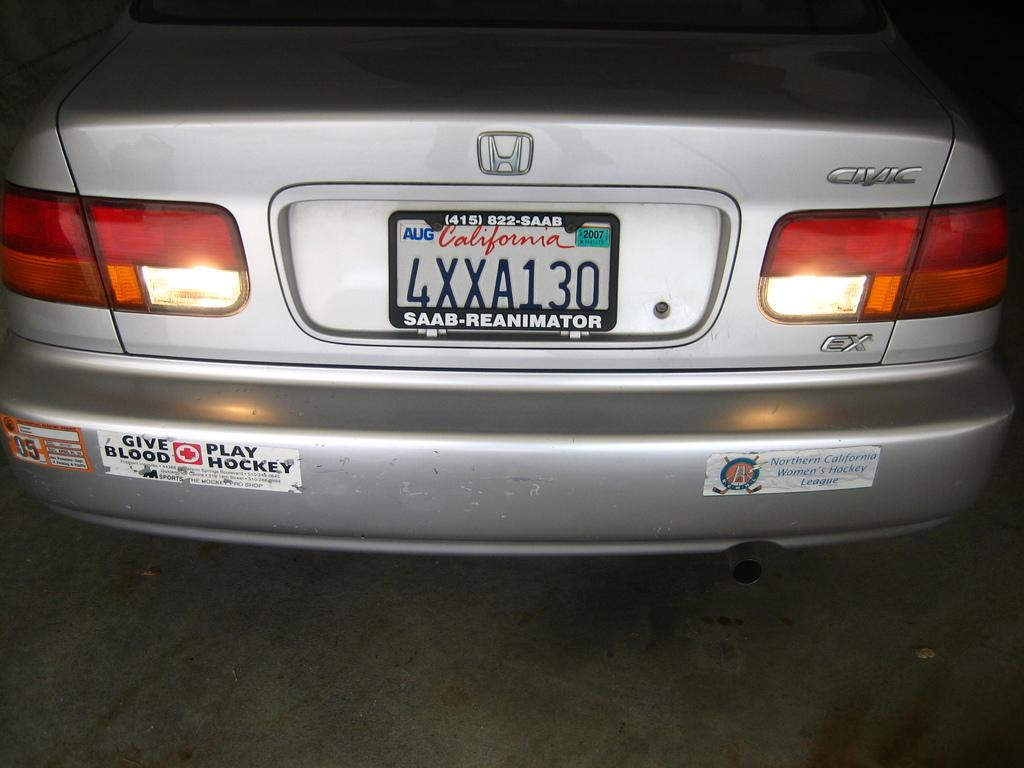<image>
Write a terse but informative summary of the picture. A Honda with a California tag that reads 4XXA130. 